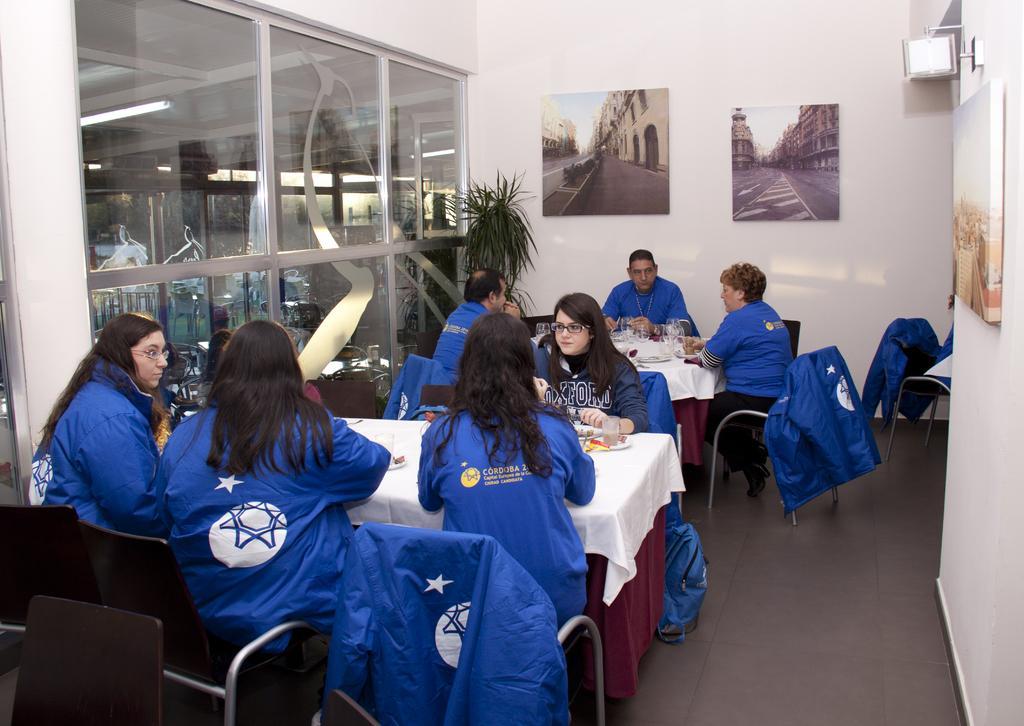In one or two sentences, can you explain what this image depicts? In this picture we can see group of the girls wearing blue color jackets sitting on the dining table and eating the food. Behind there is a big glass door and a white color wall with two hanging photo frames. 